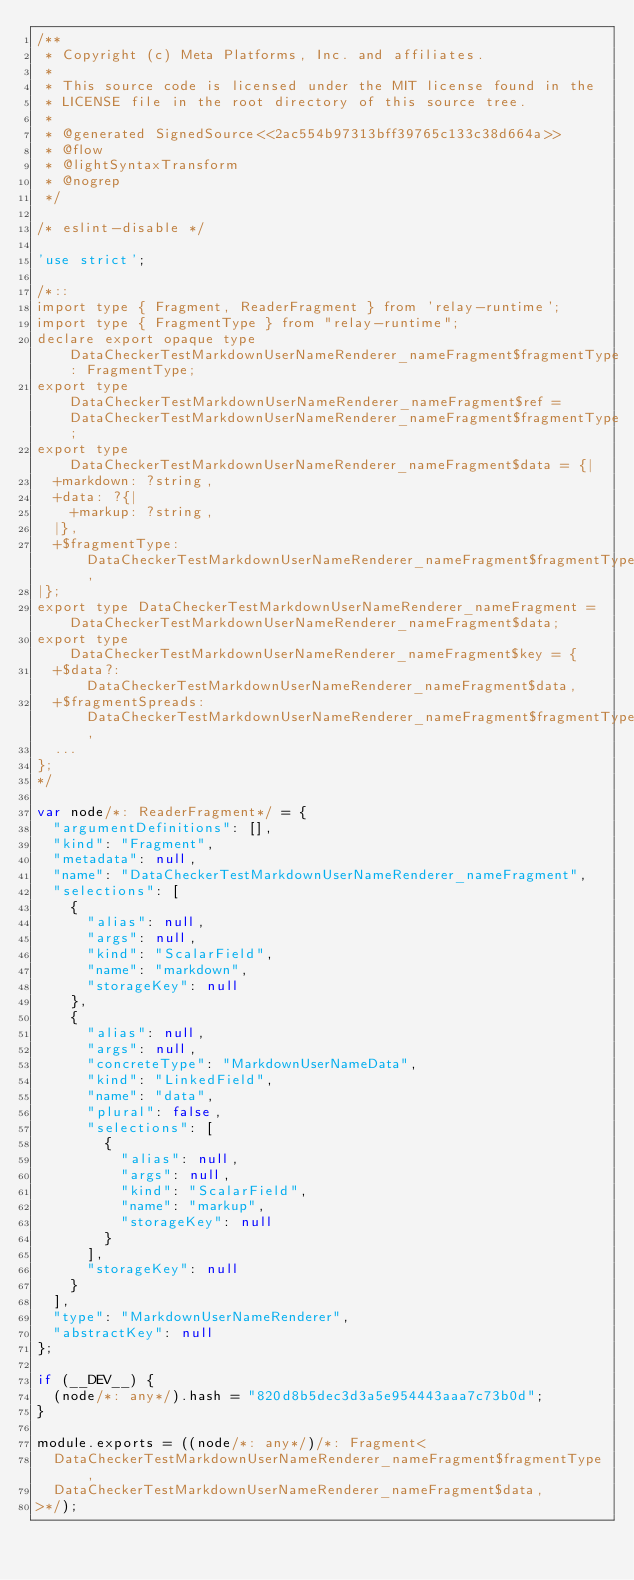<code> <loc_0><loc_0><loc_500><loc_500><_JavaScript_>/**
 * Copyright (c) Meta Platforms, Inc. and affiliates.
 * 
 * This source code is licensed under the MIT license found in the
 * LICENSE file in the root directory of this source tree.
 *
 * @generated SignedSource<<2ac554b97313bff39765c133c38d664a>>
 * @flow
 * @lightSyntaxTransform
 * @nogrep
 */

/* eslint-disable */

'use strict';

/*::
import type { Fragment, ReaderFragment } from 'relay-runtime';
import type { FragmentType } from "relay-runtime";
declare export opaque type DataCheckerTestMarkdownUserNameRenderer_nameFragment$fragmentType: FragmentType;
export type DataCheckerTestMarkdownUserNameRenderer_nameFragment$ref = DataCheckerTestMarkdownUserNameRenderer_nameFragment$fragmentType;
export type DataCheckerTestMarkdownUserNameRenderer_nameFragment$data = {|
  +markdown: ?string,
  +data: ?{|
    +markup: ?string,
  |},
  +$fragmentType: DataCheckerTestMarkdownUserNameRenderer_nameFragment$fragmentType,
|};
export type DataCheckerTestMarkdownUserNameRenderer_nameFragment = DataCheckerTestMarkdownUserNameRenderer_nameFragment$data;
export type DataCheckerTestMarkdownUserNameRenderer_nameFragment$key = {
  +$data?: DataCheckerTestMarkdownUserNameRenderer_nameFragment$data,
  +$fragmentSpreads: DataCheckerTestMarkdownUserNameRenderer_nameFragment$fragmentType,
  ...
};
*/

var node/*: ReaderFragment*/ = {
  "argumentDefinitions": [],
  "kind": "Fragment",
  "metadata": null,
  "name": "DataCheckerTestMarkdownUserNameRenderer_nameFragment",
  "selections": [
    {
      "alias": null,
      "args": null,
      "kind": "ScalarField",
      "name": "markdown",
      "storageKey": null
    },
    {
      "alias": null,
      "args": null,
      "concreteType": "MarkdownUserNameData",
      "kind": "LinkedField",
      "name": "data",
      "plural": false,
      "selections": [
        {
          "alias": null,
          "args": null,
          "kind": "ScalarField",
          "name": "markup",
          "storageKey": null
        }
      ],
      "storageKey": null
    }
  ],
  "type": "MarkdownUserNameRenderer",
  "abstractKey": null
};

if (__DEV__) {
  (node/*: any*/).hash = "820d8b5dec3d3a5e954443aaa7c73b0d";
}

module.exports = ((node/*: any*/)/*: Fragment<
  DataCheckerTestMarkdownUserNameRenderer_nameFragment$fragmentType,
  DataCheckerTestMarkdownUserNameRenderer_nameFragment$data,
>*/);
</code> 